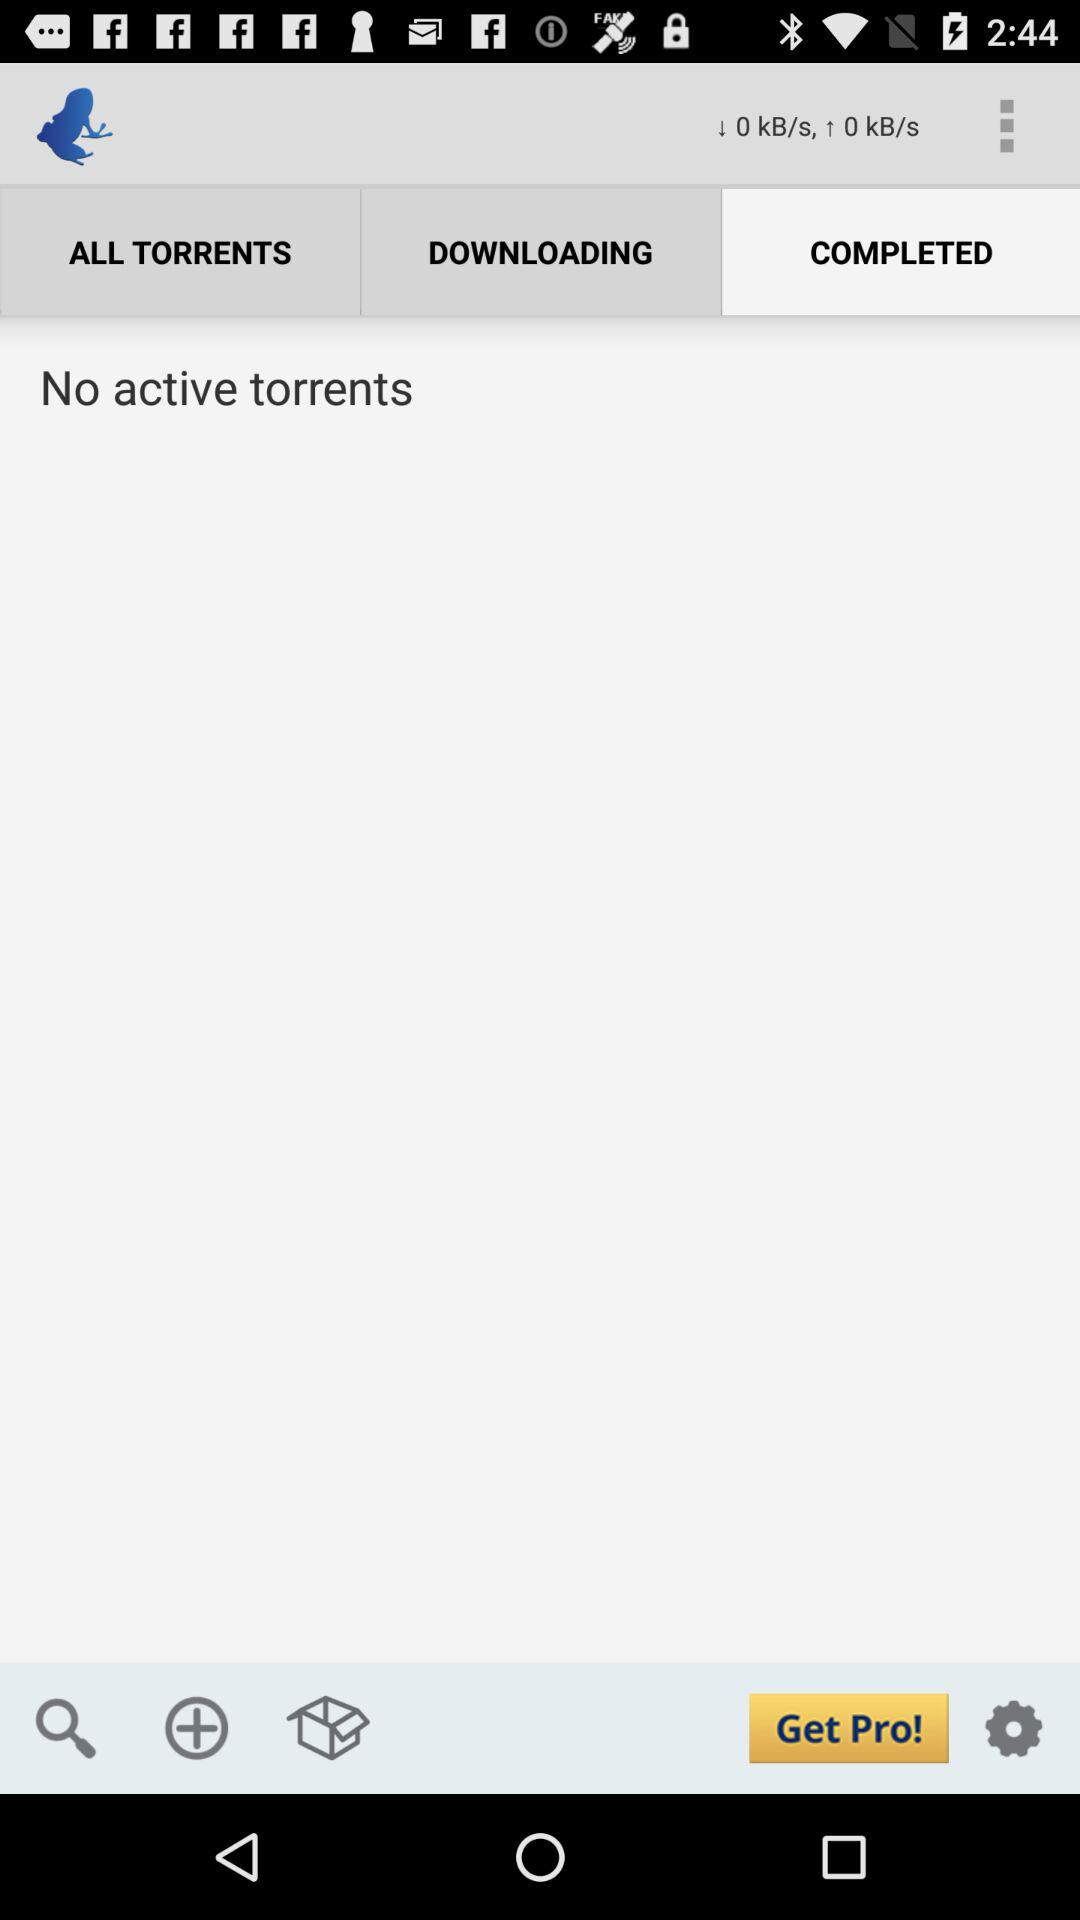Are there any active torrents? There are no active torrents. 